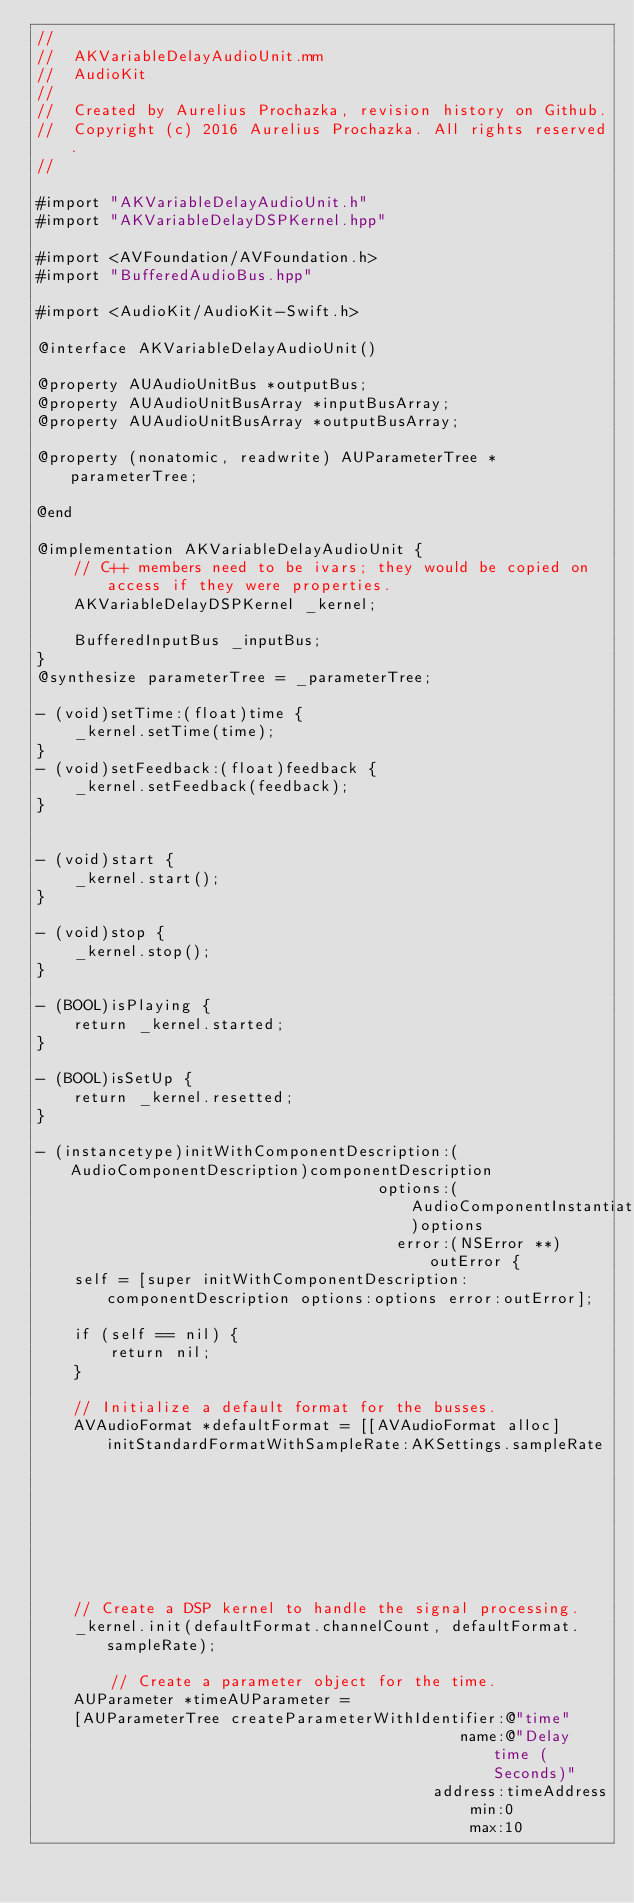<code> <loc_0><loc_0><loc_500><loc_500><_ObjectiveC_>//
//  AKVariableDelayAudioUnit.mm
//  AudioKit
//
//  Created by Aurelius Prochazka, revision history on Github.
//  Copyright (c) 2016 Aurelius Prochazka. All rights reserved.
//

#import "AKVariableDelayAudioUnit.h"
#import "AKVariableDelayDSPKernel.hpp"

#import <AVFoundation/AVFoundation.h>
#import "BufferedAudioBus.hpp"

#import <AudioKit/AudioKit-Swift.h>

@interface AKVariableDelayAudioUnit()

@property AUAudioUnitBus *outputBus;
@property AUAudioUnitBusArray *inputBusArray;
@property AUAudioUnitBusArray *outputBusArray;

@property (nonatomic, readwrite) AUParameterTree *parameterTree;

@end

@implementation AKVariableDelayAudioUnit {
    // C++ members need to be ivars; they would be copied on access if they were properties.
    AKVariableDelayDSPKernel _kernel;

    BufferedInputBus _inputBus;
}
@synthesize parameterTree = _parameterTree;

- (void)setTime:(float)time {
    _kernel.setTime(time);
}
- (void)setFeedback:(float)feedback {
    _kernel.setFeedback(feedback);
}


- (void)start {
    _kernel.start();
}

- (void)stop {
    _kernel.stop();
}

- (BOOL)isPlaying {
    return _kernel.started;
}

- (BOOL)isSetUp {
    return _kernel.resetted;
}

- (instancetype)initWithComponentDescription:(AudioComponentDescription)componentDescription
                                     options:(AudioComponentInstantiationOptions)options
                                       error:(NSError **)outError {
    self = [super initWithComponentDescription:componentDescription options:options error:outError];

    if (self == nil) {
        return nil;
    }

    // Initialize a default format for the busses.
    AVAudioFormat *defaultFormat = [[AVAudioFormat alloc] initStandardFormatWithSampleRate:AKSettings.sampleRate
                                                                                  channels:AKSettings.numberOfChannels];

    // Create a DSP kernel to handle the signal processing.
    _kernel.init(defaultFormat.channelCount, defaultFormat.sampleRate);

        // Create a parameter object for the time.
    AUParameter *timeAUParameter =
    [AUParameterTree createParameterWithIdentifier:@"time"
                                              name:@"Delay time (Seconds)"
                                           address:timeAddress
                                               min:0
                                               max:10</code> 